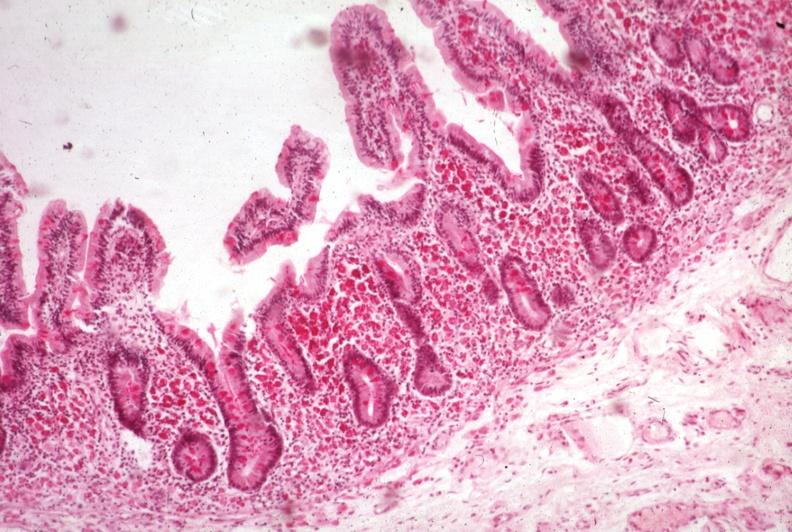does normal newborn show pas hematoxylin?
Answer the question using a single word or phrase. No 